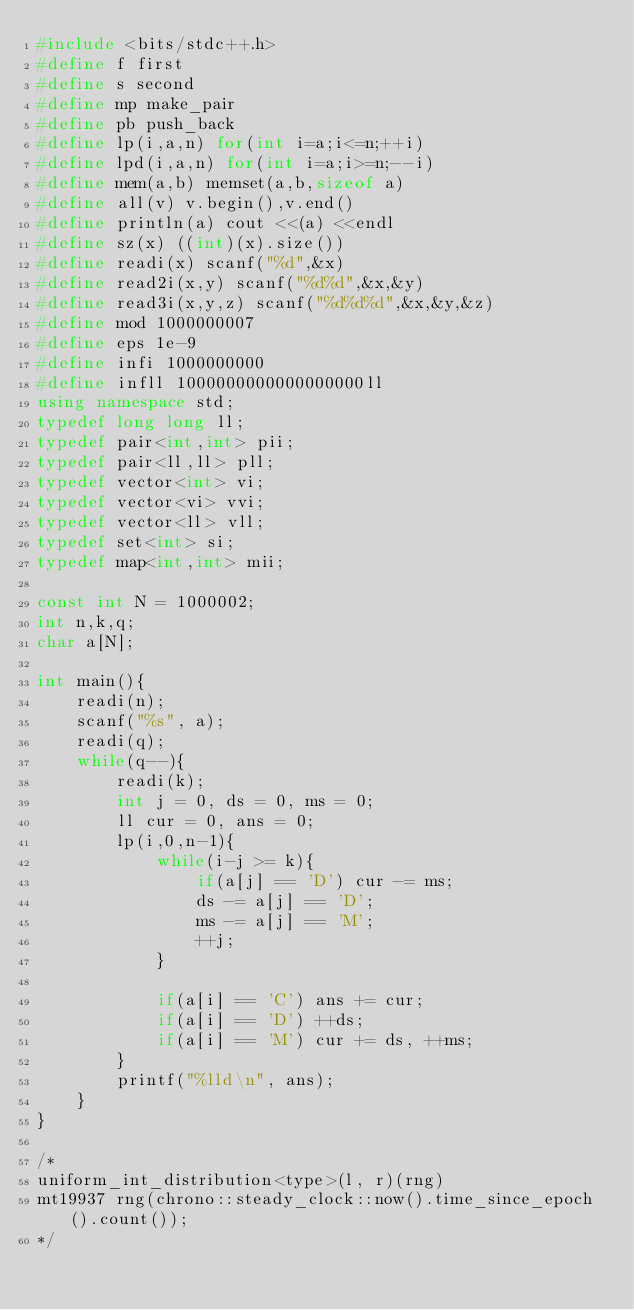Convert code to text. <code><loc_0><loc_0><loc_500><loc_500><_C++_>#include <bits/stdc++.h>
#define f first
#define s second
#define mp make_pair
#define pb push_back
#define lp(i,a,n) for(int i=a;i<=n;++i)
#define lpd(i,a,n) for(int i=a;i>=n;--i)
#define mem(a,b) memset(a,b,sizeof a)
#define all(v) v.begin(),v.end()
#define println(a) cout <<(a) <<endl
#define sz(x) ((int)(x).size())
#define readi(x) scanf("%d",&x)
#define read2i(x,y) scanf("%d%d",&x,&y)
#define read3i(x,y,z) scanf("%d%d%d",&x,&y,&z)
#define mod 1000000007
#define eps 1e-9
#define infi 1000000000
#define infll 1000000000000000000ll
using namespace std;
typedef long long ll;
typedef pair<int,int> pii;
typedef pair<ll,ll> pll;
typedef vector<int> vi;
typedef vector<vi> vvi;
typedef vector<ll> vll;
typedef set<int> si;
typedef map<int,int> mii;

const int N = 1000002;
int n,k,q;
char a[N];

int main(){
    readi(n);
    scanf("%s", a);
    readi(q);
    while(q--){
        readi(k);
        int j = 0, ds = 0, ms = 0;
        ll cur = 0, ans = 0;
        lp(i,0,n-1){
            while(i-j >= k){
                if(a[j] == 'D') cur -= ms;
                ds -= a[j] == 'D';
                ms -= a[j] == 'M';
                ++j;
            }

            if(a[i] == 'C') ans += cur;
            if(a[i] == 'D') ++ds;
            if(a[i] == 'M') cur += ds, ++ms;
        }
        printf("%lld\n", ans);
    }
}

/*
uniform_int_distribution<type>(l, r)(rng)
mt19937 rng(chrono::steady_clock::now().time_since_epoch().count());
*/
</code> 